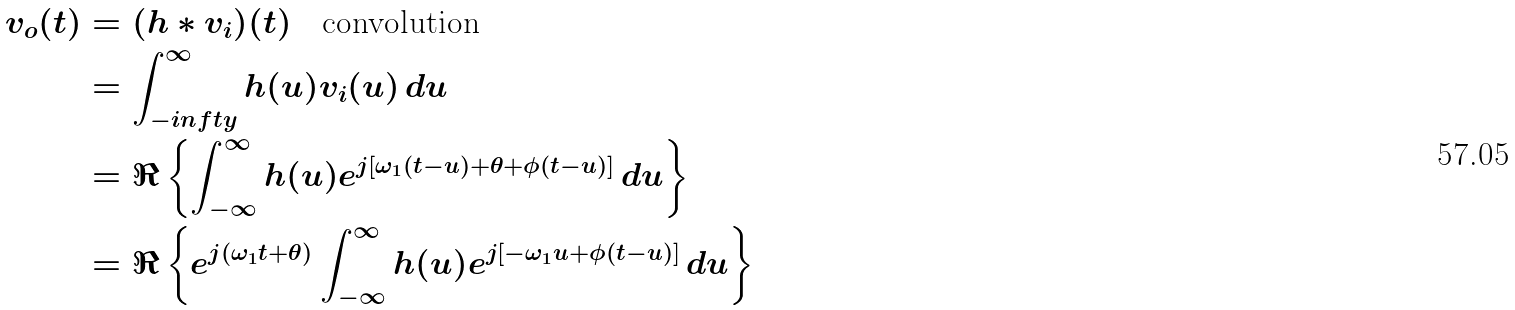Convert formula to latex. <formula><loc_0><loc_0><loc_500><loc_500>v _ { o } ( t ) & = ( h * v _ { i } ) ( t ) \quad \text {convolution} \\ & = \int _ { - i n f t y } ^ { \infty } h ( u ) v _ { i } ( u ) \, d u \\ & = \Re \left \{ \int _ { - \infty } ^ { \infty } h ( u ) e ^ { j [ \omega _ { 1 } ( t - u ) + \theta + \phi ( t - u ) ] } \, d u \right \} \\ & = \Re \left \{ e ^ { j ( \omega _ { 1 } t + \theta ) } \int _ { - \infty } ^ { \infty } h ( u ) e ^ { j [ - \omega _ { 1 } u + \phi ( t - u ) ] } \, d u \right \}</formula> 